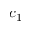Convert formula to latex. <formula><loc_0><loc_0><loc_500><loc_500>c _ { 1 }</formula> 